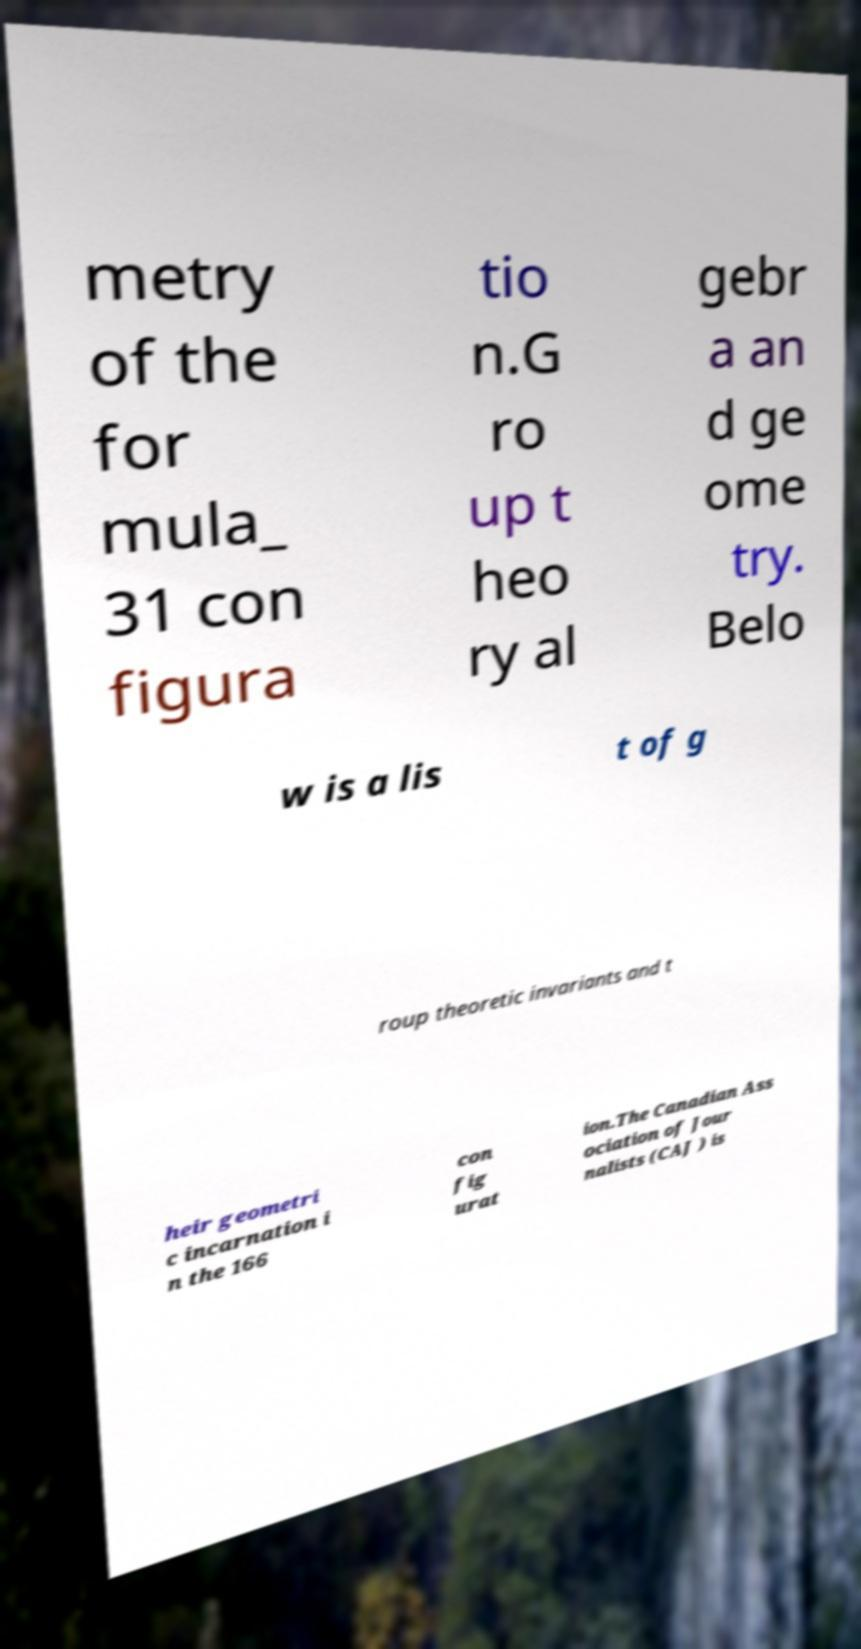There's text embedded in this image that I need extracted. Can you transcribe it verbatim? metry of the for mula_ 31 con figura tio n.G ro up t heo ry al gebr a an d ge ome try. Belo w is a lis t of g roup theoretic invariants and t heir geometri c incarnation i n the 166 con fig urat ion.The Canadian Ass ociation of Jour nalists (CAJ ) is 